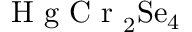<formula> <loc_0><loc_0><loc_500><loc_500>H g C r _ { 2 } S e _ { 4 }</formula> 